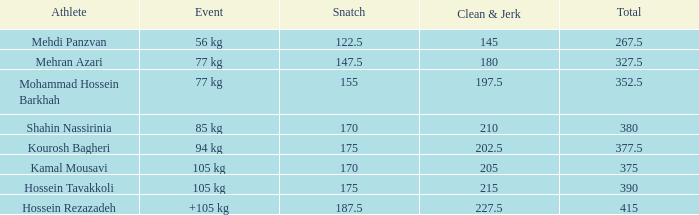What count of snatches results in a sum of 267.5? 0.0. 